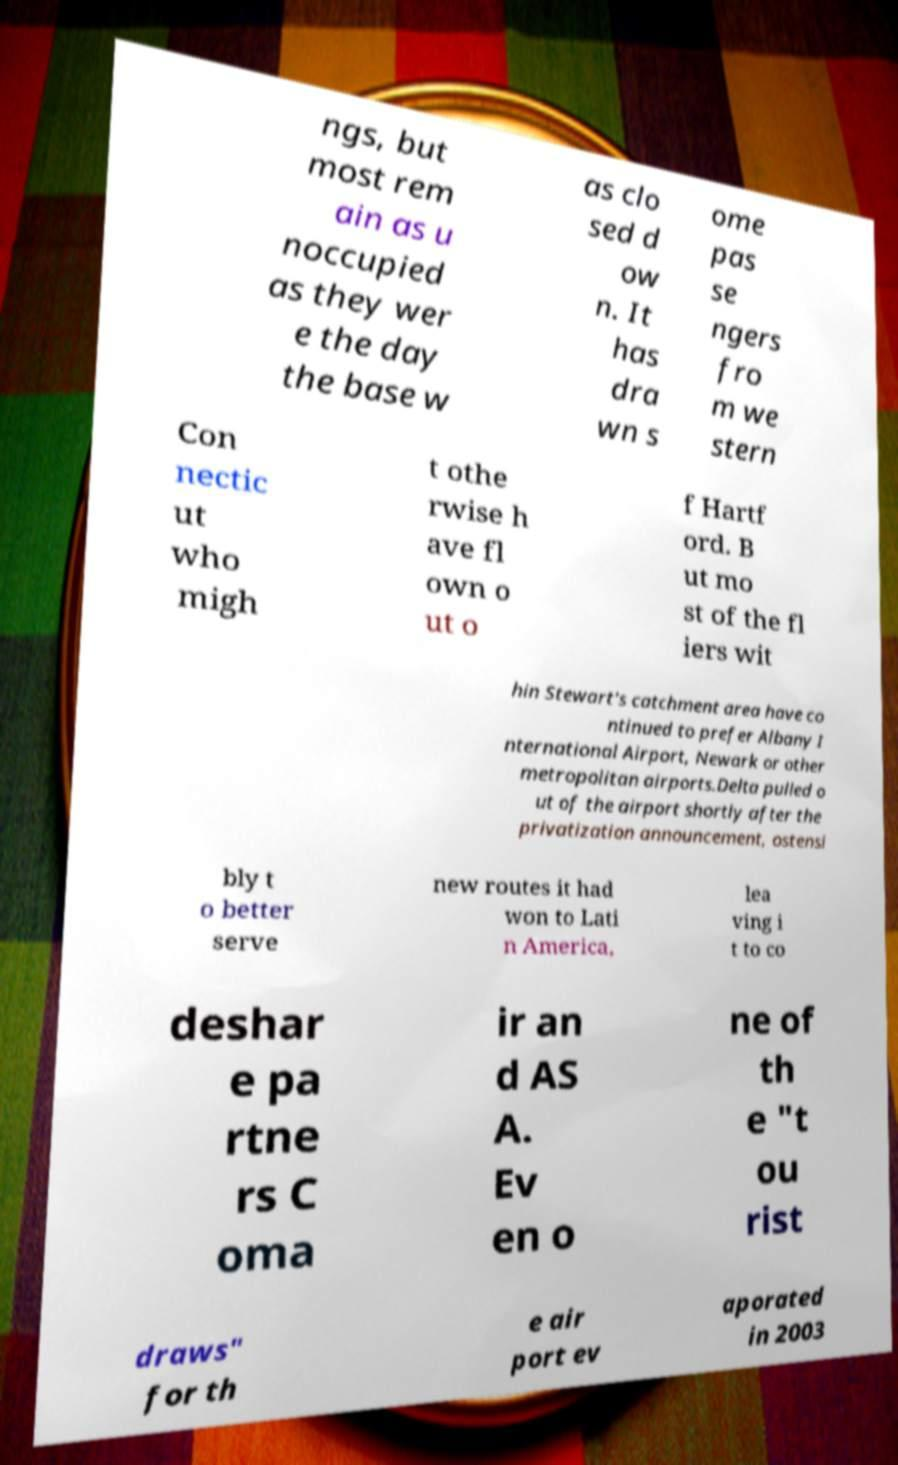Could you assist in decoding the text presented in this image and type it out clearly? ngs, but most rem ain as u noccupied as they wer e the day the base w as clo sed d ow n. It has dra wn s ome pas se ngers fro m we stern Con nectic ut who migh t othe rwise h ave fl own o ut o f Hartf ord. B ut mo st of the fl iers wit hin Stewart's catchment area have co ntinued to prefer Albany I nternational Airport, Newark or other metropolitan airports.Delta pulled o ut of the airport shortly after the privatization announcement, ostensi bly t o better serve new routes it had won to Lati n America, lea ving i t to co deshar e pa rtne rs C oma ir an d AS A. Ev en o ne of th e "t ou rist draws" for th e air port ev aporated in 2003 